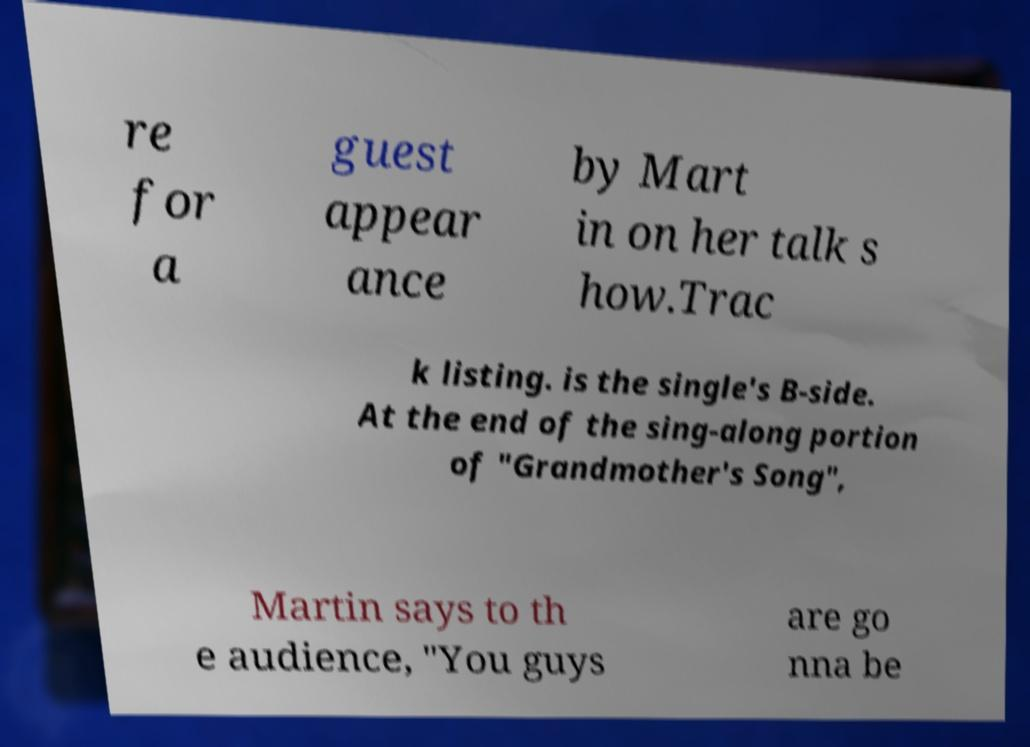Can you read and provide the text displayed in the image?This photo seems to have some interesting text. Can you extract and type it out for me? re for a guest appear ance by Mart in on her talk s how.Trac k listing. is the single's B-side. At the end of the sing-along portion of "Grandmother's Song", Martin says to th e audience, "You guys are go nna be 